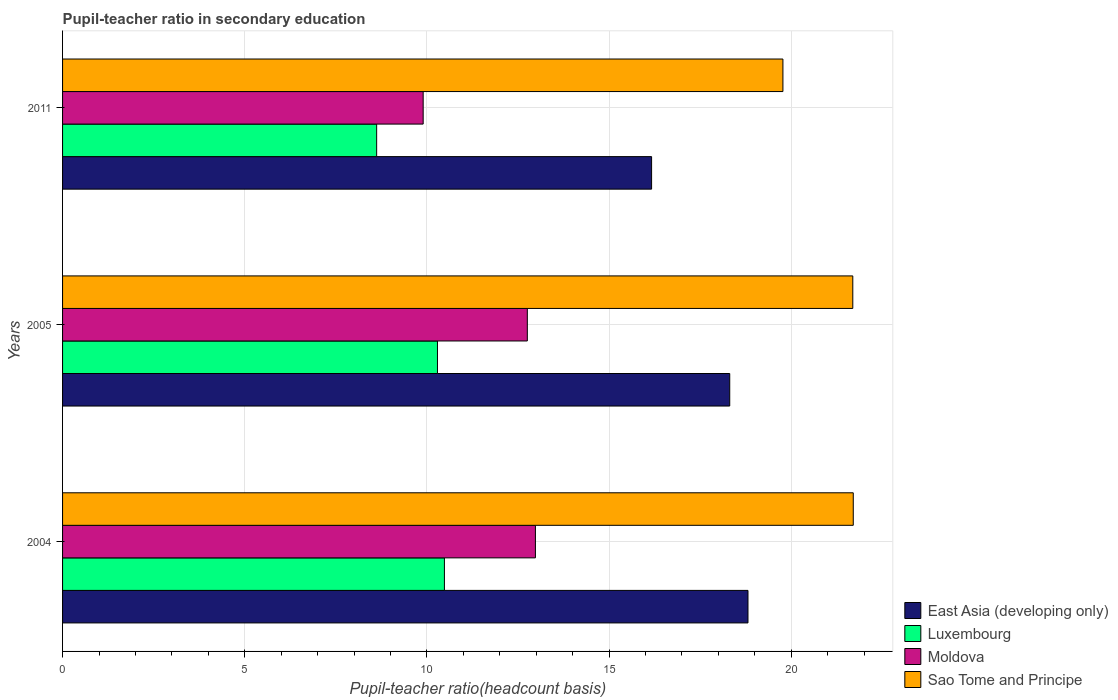How many bars are there on the 2nd tick from the top?
Offer a terse response. 4. How many bars are there on the 3rd tick from the bottom?
Provide a short and direct response. 4. What is the label of the 2nd group of bars from the top?
Your answer should be compact. 2005. In how many cases, is the number of bars for a given year not equal to the number of legend labels?
Give a very brief answer. 0. What is the pupil-teacher ratio in secondary education in Sao Tome and Principe in 2004?
Keep it short and to the point. 21.7. Across all years, what is the maximum pupil-teacher ratio in secondary education in Moldova?
Keep it short and to the point. 12.98. Across all years, what is the minimum pupil-teacher ratio in secondary education in Moldova?
Give a very brief answer. 9.9. What is the total pupil-teacher ratio in secondary education in Luxembourg in the graph?
Your answer should be compact. 29.39. What is the difference between the pupil-teacher ratio in secondary education in Luxembourg in 2004 and that in 2005?
Offer a terse response. 0.19. What is the difference between the pupil-teacher ratio in secondary education in Moldova in 2004 and the pupil-teacher ratio in secondary education in Luxembourg in 2011?
Your answer should be very brief. 4.36. What is the average pupil-teacher ratio in secondary education in Moldova per year?
Your answer should be very brief. 11.88. In the year 2011, what is the difference between the pupil-teacher ratio in secondary education in Sao Tome and Principe and pupil-teacher ratio in secondary education in Luxembourg?
Keep it short and to the point. 11.15. What is the ratio of the pupil-teacher ratio in secondary education in Moldova in 2004 to that in 2005?
Your response must be concise. 1.02. Is the pupil-teacher ratio in secondary education in Sao Tome and Principe in 2004 less than that in 2005?
Offer a terse response. No. Is the difference between the pupil-teacher ratio in secondary education in Sao Tome and Principe in 2004 and 2011 greater than the difference between the pupil-teacher ratio in secondary education in Luxembourg in 2004 and 2011?
Provide a succinct answer. Yes. What is the difference between the highest and the second highest pupil-teacher ratio in secondary education in East Asia (developing only)?
Your answer should be compact. 0.5. What is the difference between the highest and the lowest pupil-teacher ratio in secondary education in Sao Tome and Principe?
Provide a succinct answer. 1.93. Is the sum of the pupil-teacher ratio in secondary education in Moldova in 2005 and 2011 greater than the maximum pupil-teacher ratio in secondary education in East Asia (developing only) across all years?
Make the answer very short. Yes. Is it the case that in every year, the sum of the pupil-teacher ratio in secondary education in Sao Tome and Principe and pupil-teacher ratio in secondary education in Moldova is greater than the sum of pupil-teacher ratio in secondary education in East Asia (developing only) and pupil-teacher ratio in secondary education in Luxembourg?
Your answer should be very brief. Yes. What does the 2nd bar from the top in 2004 represents?
Offer a very short reply. Moldova. What does the 2nd bar from the bottom in 2011 represents?
Offer a very short reply. Luxembourg. How many bars are there?
Give a very brief answer. 12. Are all the bars in the graph horizontal?
Offer a very short reply. Yes. Does the graph contain any zero values?
Ensure brevity in your answer.  No. Where does the legend appear in the graph?
Keep it short and to the point. Bottom right. How many legend labels are there?
Your answer should be very brief. 4. What is the title of the graph?
Offer a very short reply. Pupil-teacher ratio in secondary education. What is the label or title of the X-axis?
Keep it short and to the point. Pupil-teacher ratio(headcount basis). What is the Pupil-teacher ratio(headcount basis) of East Asia (developing only) in 2004?
Offer a terse response. 18.81. What is the Pupil-teacher ratio(headcount basis) of Luxembourg in 2004?
Make the answer very short. 10.48. What is the Pupil-teacher ratio(headcount basis) in Moldova in 2004?
Give a very brief answer. 12.98. What is the Pupil-teacher ratio(headcount basis) of Sao Tome and Principe in 2004?
Your answer should be very brief. 21.7. What is the Pupil-teacher ratio(headcount basis) of East Asia (developing only) in 2005?
Keep it short and to the point. 18.31. What is the Pupil-teacher ratio(headcount basis) of Luxembourg in 2005?
Your answer should be compact. 10.29. What is the Pupil-teacher ratio(headcount basis) in Moldova in 2005?
Offer a very short reply. 12.76. What is the Pupil-teacher ratio(headcount basis) in Sao Tome and Principe in 2005?
Keep it short and to the point. 21.69. What is the Pupil-teacher ratio(headcount basis) in East Asia (developing only) in 2011?
Offer a terse response. 16.17. What is the Pupil-teacher ratio(headcount basis) of Luxembourg in 2011?
Offer a terse response. 8.62. What is the Pupil-teacher ratio(headcount basis) in Moldova in 2011?
Offer a very short reply. 9.9. What is the Pupil-teacher ratio(headcount basis) in Sao Tome and Principe in 2011?
Provide a short and direct response. 19.77. Across all years, what is the maximum Pupil-teacher ratio(headcount basis) in East Asia (developing only)?
Offer a terse response. 18.81. Across all years, what is the maximum Pupil-teacher ratio(headcount basis) in Luxembourg?
Ensure brevity in your answer.  10.48. Across all years, what is the maximum Pupil-teacher ratio(headcount basis) in Moldova?
Offer a terse response. 12.98. Across all years, what is the maximum Pupil-teacher ratio(headcount basis) of Sao Tome and Principe?
Provide a short and direct response. 21.7. Across all years, what is the minimum Pupil-teacher ratio(headcount basis) in East Asia (developing only)?
Give a very brief answer. 16.17. Across all years, what is the minimum Pupil-teacher ratio(headcount basis) of Luxembourg?
Provide a short and direct response. 8.62. Across all years, what is the minimum Pupil-teacher ratio(headcount basis) in Moldova?
Your answer should be compact. 9.9. Across all years, what is the minimum Pupil-teacher ratio(headcount basis) of Sao Tome and Principe?
Keep it short and to the point. 19.77. What is the total Pupil-teacher ratio(headcount basis) of East Asia (developing only) in the graph?
Make the answer very short. 53.3. What is the total Pupil-teacher ratio(headcount basis) of Luxembourg in the graph?
Make the answer very short. 29.39. What is the total Pupil-teacher ratio(headcount basis) of Moldova in the graph?
Give a very brief answer. 35.64. What is the total Pupil-teacher ratio(headcount basis) in Sao Tome and Principe in the graph?
Your answer should be compact. 63.17. What is the difference between the Pupil-teacher ratio(headcount basis) in East Asia (developing only) in 2004 and that in 2005?
Offer a terse response. 0.5. What is the difference between the Pupil-teacher ratio(headcount basis) in Luxembourg in 2004 and that in 2005?
Ensure brevity in your answer.  0.19. What is the difference between the Pupil-teacher ratio(headcount basis) of Moldova in 2004 and that in 2005?
Your response must be concise. 0.22. What is the difference between the Pupil-teacher ratio(headcount basis) of Sao Tome and Principe in 2004 and that in 2005?
Provide a succinct answer. 0.01. What is the difference between the Pupil-teacher ratio(headcount basis) of East Asia (developing only) in 2004 and that in 2011?
Provide a succinct answer. 2.65. What is the difference between the Pupil-teacher ratio(headcount basis) of Luxembourg in 2004 and that in 2011?
Your response must be concise. 1.86. What is the difference between the Pupil-teacher ratio(headcount basis) of Moldova in 2004 and that in 2011?
Make the answer very short. 3.08. What is the difference between the Pupil-teacher ratio(headcount basis) of Sao Tome and Principe in 2004 and that in 2011?
Give a very brief answer. 1.93. What is the difference between the Pupil-teacher ratio(headcount basis) of East Asia (developing only) in 2005 and that in 2011?
Offer a terse response. 2.15. What is the difference between the Pupil-teacher ratio(headcount basis) in Luxembourg in 2005 and that in 2011?
Your answer should be compact. 1.67. What is the difference between the Pupil-teacher ratio(headcount basis) of Moldova in 2005 and that in 2011?
Offer a terse response. 2.86. What is the difference between the Pupil-teacher ratio(headcount basis) in Sao Tome and Principe in 2005 and that in 2011?
Your answer should be compact. 1.92. What is the difference between the Pupil-teacher ratio(headcount basis) in East Asia (developing only) in 2004 and the Pupil-teacher ratio(headcount basis) in Luxembourg in 2005?
Offer a terse response. 8.52. What is the difference between the Pupil-teacher ratio(headcount basis) in East Asia (developing only) in 2004 and the Pupil-teacher ratio(headcount basis) in Moldova in 2005?
Offer a terse response. 6.06. What is the difference between the Pupil-teacher ratio(headcount basis) in East Asia (developing only) in 2004 and the Pupil-teacher ratio(headcount basis) in Sao Tome and Principe in 2005?
Ensure brevity in your answer.  -2.88. What is the difference between the Pupil-teacher ratio(headcount basis) of Luxembourg in 2004 and the Pupil-teacher ratio(headcount basis) of Moldova in 2005?
Keep it short and to the point. -2.28. What is the difference between the Pupil-teacher ratio(headcount basis) in Luxembourg in 2004 and the Pupil-teacher ratio(headcount basis) in Sao Tome and Principe in 2005?
Your answer should be very brief. -11.21. What is the difference between the Pupil-teacher ratio(headcount basis) in Moldova in 2004 and the Pupil-teacher ratio(headcount basis) in Sao Tome and Principe in 2005?
Provide a succinct answer. -8.71. What is the difference between the Pupil-teacher ratio(headcount basis) in East Asia (developing only) in 2004 and the Pupil-teacher ratio(headcount basis) in Luxembourg in 2011?
Your answer should be very brief. 10.19. What is the difference between the Pupil-teacher ratio(headcount basis) in East Asia (developing only) in 2004 and the Pupil-teacher ratio(headcount basis) in Moldova in 2011?
Your response must be concise. 8.92. What is the difference between the Pupil-teacher ratio(headcount basis) in East Asia (developing only) in 2004 and the Pupil-teacher ratio(headcount basis) in Sao Tome and Principe in 2011?
Ensure brevity in your answer.  -0.96. What is the difference between the Pupil-teacher ratio(headcount basis) in Luxembourg in 2004 and the Pupil-teacher ratio(headcount basis) in Moldova in 2011?
Give a very brief answer. 0.58. What is the difference between the Pupil-teacher ratio(headcount basis) in Luxembourg in 2004 and the Pupil-teacher ratio(headcount basis) in Sao Tome and Principe in 2011?
Your answer should be compact. -9.29. What is the difference between the Pupil-teacher ratio(headcount basis) of Moldova in 2004 and the Pupil-teacher ratio(headcount basis) of Sao Tome and Principe in 2011?
Your answer should be compact. -6.79. What is the difference between the Pupil-teacher ratio(headcount basis) in East Asia (developing only) in 2005 and the Pupil-teacher ratio(headcount basis) in Luxembourg in 2011?
Keep it short and to the point. 9.69. What is the difference between the Pupil-teacher ratio(headcount basis) in East Asia (developing only) in 2005 and the Pupil-teacher ratio(headcount basis) in Moldova in 2011?
Provide a succinct answer. 8.42. What is the difference between the Pupil-teacher ratio(headcount basis) in East Asia (developing only) in 2005 and the Pupil-teacher ratio(headcount basis) in Sao Tome and Principe in 2011?
Offer a very short reply. -1.46. What is the difference between the Pupil-teacher ratio(headcount basis) of Luxembourg in 2005 and the Pupil-teacher ratio(headcount basis) of Moldova in 2011?
Your answer should be very brief. 0.39. What is the difference between the Pupil-teacher ratio(headcount basis) of Luxembourg in 2005 and the Pupil-teacher ratio(headcount basis) of Sao Tome and Principe in 2011?
Keep it short and to the point. -9.48. What is the difference between the Pupil-teacher ratio(headcount basis) of Moldova in 2005 and the Pupil-teacher ratio(headcount basis) of Sao Tome and Principe in 2011?
Your answer should be very brief. -7.02. What is the average Pupil-teacher ratio(headcount basis) of East Asia (developing only) per year?
Your answer should be compact. 17.77. What is the average Pupil-teacher ratio(headcount basis) in Luxembourg per year?
Give a very brief answer. 9.8. What is the average Pupil-teacher ratio(headcount basis) of Moldova per year?
Give a very brief answer. 11.88. What is the average Pupil-teacher ratio(headcount basis) in Sao Tome and Principe per year?
Your answer should be compact. 21.06. In the year 2004, what is the difference between the Pupil-teacher ratio(headcount basis) in East Asia (developing only) and Pupil-teacher ratio(headcount basis) in Luxembourg?
Your response must be concise. 8.33. In the year 2004, what is the difference between the Pupil-teacher ratio(headcount basis) in East Asia (developing only) and Pupil-teacher ratio(headcount basis) in Moldova?
Your answer should be compact. 5.84. In the year 2004, what is the difference between the Pupil-teacher ratio(headcount basis) in East Asia (developing only) and Pupil-teacher ratio(headcount basis) in Sao Tome and Principe?
Offer a very short reply. -2.89. In the year 2004, what is the difference between the Pupil-teacher ratio(headcount basis) in Luxembourg and Pupil-teacher ratio(headcount basis) in Moldova?
Provide a succinct answer. -2.5. In the year 2004, what is the difference between the Pupil-teacher ratio(headcount basis) in Luxembourg and Pupil-teacher ratio(headcount basis) in Sao Tome and Principe?
Provide a short and direct response. -11.22. In the year 2004, what is the difference between the Pupil-teacher ratio(headcount basis) in Moldova and Pupil-teacher ratio(headcount basis) in Sao Tome and Principe?
Offer a very short reply. -8.73. In the year 2005, what is the difference between the Pupil-teacher ratio(headcount basis) in East Asia (developing only) and Pupil-teacher ratio(headcount basis) in Luxembourg?
Make the answer very short. 8.02. In the year 2005, what is the difference between the Pupil-teacher ratio(headcount basis) in East Asia (developing only) and Pupil-teacher ratio(headcount basis) in Moldova?
Ensure brevity in your answer.  5.56. In the year 2005, what is the difference between the Pupil-teacher ratio(headcount basis) of East Asia (developing only) and Pupil-teacher ratio(headcount basis) of Sao Tome and Principe?
Make the answer very short. -3.38. In the year 2005, what is the difference between the Pupil-teacher ratio(headcount basis) of Luxembourg and Pupil-teacher ratio(headcount basis) of Moldova?
Your answer should be very brief. -2.47. In the year 2005, what is the difference between the Pupil-teacher ratio(headcount basis) of Luxembourg and Pupil-teacher ratio(headcount basis) of Sao Tome and Principe?
Provide a succinct answer. -11.4. In the year 2005, what is the difference between the Pupil-teacher ratio(headcount basis) in Moldova and Pupil-teacher ratio(headcount basis) in Sao Tome and Principe?
Make the answer very short. -8.93. In the year 2011, what is the difference between the Pupil-teacher ratio(headcount basis) of East Asia (developing only) and Pupil-teacher ratio(headcount basis) of Luxembourg?
Offer a terse response. 7.55. In the year 2011, what is the difference between the Pupil-teacher ratio(headcount basis) of East Asia (developing only) and Pupil-teacher ratio(headcount basis) of Moldova?
Your answer should be compact. 6.27. In the year 2011, what is the difference between the Pupil-teacher ratio(headcount basis) in East Asia (developing only) and Pupil-teacher ratio(headcount basis) in Sao Tome and Principe?
Your answer should be very brief. -3.61. In the year 2011, what is the difference between the Pupil-teacher ratio(headcount basis) in Luxembourg and Pupil-teacher ratio(headcount basis) in Moldova?
Your answer should be compact. -1.28. In the year 2011, what is the difference between the Pupil-teacher ratio(headcount basis) in Luxembourg and Pupil-teacher ratio(headcount basis) in Sao Tome and Principe?
Make the answer very short. -11.15. In the year 2011, what is the difference between the Pupil-teacher ratio(headcount basis) in Moldova and Pupil-teacher ratio(headcount basis) in Sao Tome and Principe?
Provide a short and direct response. -9.88. What is the ratio of the Pupil-teacher ratio(headcount basis) in East Asia (developing only) in 2004 to that in 2005?
Ensure brevity in your answer.  1.03. What is the ratio of the Pupil-teacher ratio(headcount basis) of Luxembourg in 2004 to that in 2005?
Keep it short and to the point. 1.02. What is the ratio of the Pupil-teacher ratio(headcount basis) in Moldova in 2004 to that in 2005?
Offer a very short reply. 1.02. What is the ratio of the Pupil-teacher ratio(headcount basis) in Sao Tome and Principe in 2004 to that in 2005?
Provide a short and direct response. 1. What is the ratio of the Pupil-teacher ratio(headcount basis) in East Asia (developing only) in 2004 to that in 2011?
Provide a succinct answer. 1.16. What is the ratio of the Pupil-teacher ratio(headcount basis) in Luxembourg in 2004 to that in 2011?
Provide a short and direct response. 1.22. What is the ratio of the Pupil-teacher ratio(headcount basis) in Moldova in 2004 to that in 2011?
Your response must be concise. 1.31. What is the ratio of the Pupil-teacher ratio(headcount basis) of Sao Tome and Principe in 2004 to that in 2011?
Give a very brief answer. 1.1. What is the ratio of the Pupil-teacher ratio(headcount basis) of East Asia (developing only) in 2005 to that in 2011?
Ensure brevity in your answer.  1.13. What is the ratio of the Pupil-teacher ratio(headcount basis) in Luxembourg in 2005 to that in 2011?
Your answer should be very brief. 1.19. What is the ratio of the Pupil-teacher ratio(headcount basis) of Moldova in 2005 to that in 2011?
Keep it short and to the point. 1.29. What is the ratio of the Pupil-teacher ratio(headcount basis) of Sao Tome and Principe in 2005 to that in 2011?
Provide a short and direct response. 1.1. What is the difference between the highest and the second highest Pupil-teacher ratio(headcount basis) of East Asia (developing only)?
Your response must be concise. 0.5. What is the difference between the highest and the second highest Pupil-teacher ratio(headcount basis) in Luxembourg?
Your answer should be compact. 0.19. What is the difference between the highest and the second highest Pupil-teacher ratio(headcount basis) of Moldova?
Your answer should be very brief. 0.22. What is the difference between the highest and the second highest Pupil-teacher ratio(headcount basis) in Sao Tome and Principe?
Your response must be concise. 0.01. What is the difference between the highest and the lowest Pupil-teacher ratio(headcount basis) in East Asia (developing only)?
Your response must be concise. 2.65. What is the difference between the highest and the lowest Pupil-teacher ratio(headcount basis) in Luxembourg?
Your answer should be very brief. 1.86. What is the difference between the highest and the lowest Pupil-teacher ratio(headcount basis) in Moldova?
Your answer should be very brief. 3.08. What is the difference between the highest and the lowest Pupil-teacher ratio(headcount basis) of Sao Tome and Principe?
Keep it short and to the point. 1.93. 